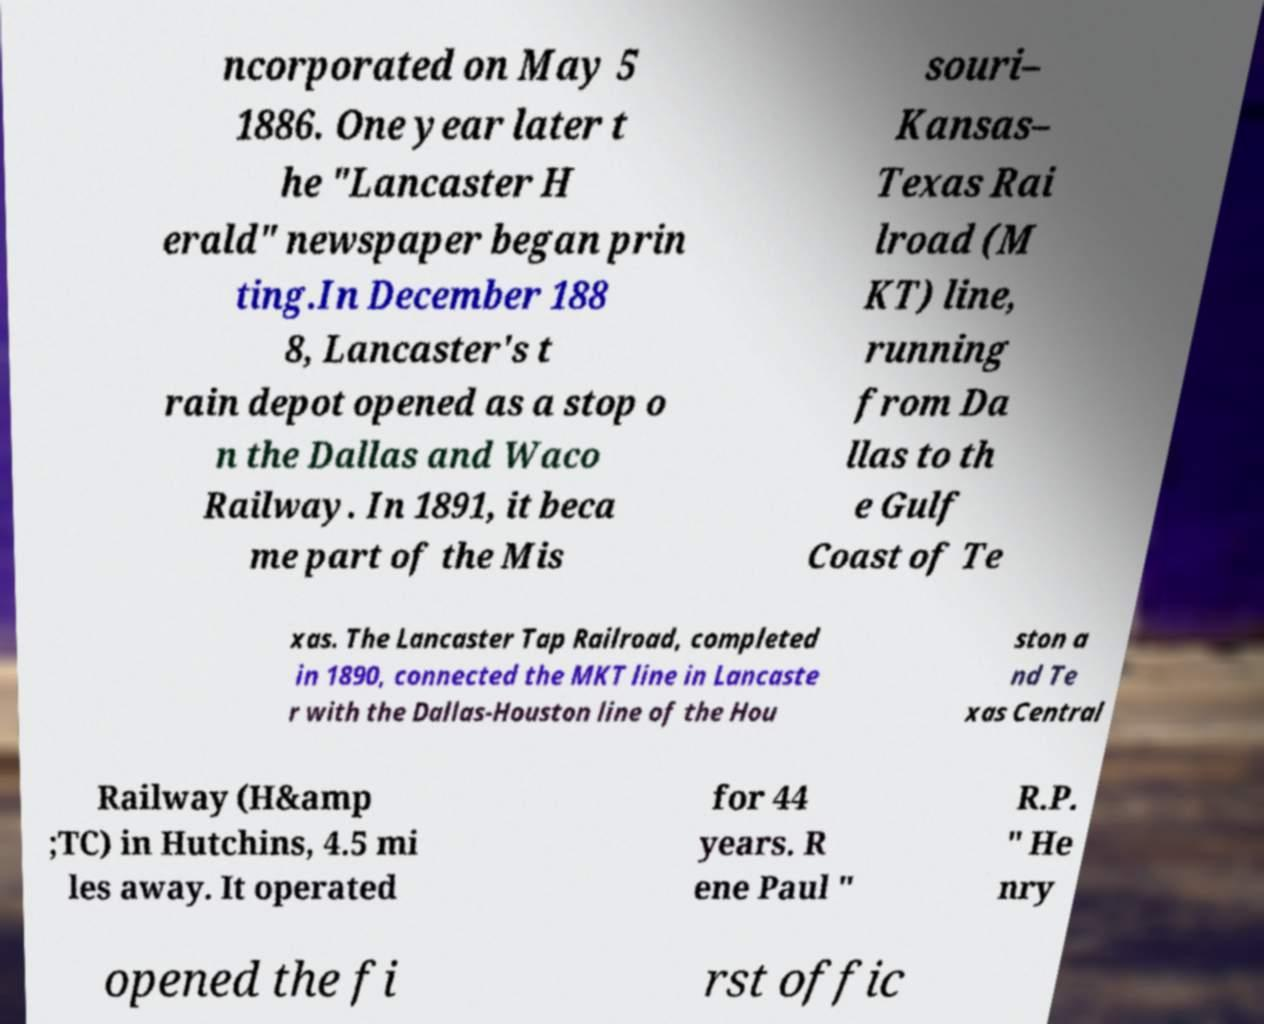What messages or text are displayed in this image? I need them in a readable, typed format. ncorporated on May 5 1886. One year later t he "Lancaster H erald" newspaper began prin ting.In December 188 8, Lancaster's t rain depot opened as a stop o n the Dallas and Waco Railway. In 1891, it beca me part of the Mis souri– Kansas– Texas Rai lroad (M KT) line, running from Da llas to th e Gulf Coast of Te xas. The Lancaster Tap Railroad, completed in 1890, connected the MKT line in Lancaste r with the Dallas-Houston line of the Hou ston a nd Te xas Central Railway (H&amp ;TC) in Hutchins, 4.5 mi les away. It operated for 44 years. R ene Paul " R.P. " He nry opened the fi rst offic 